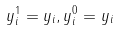<formula> <loc_0><loc_0><loc_500><loc_500>y _ { i } ^ { 1 } = y _ { i } , y _ { i } ^ { 0 } = y _ { i }</formula> 